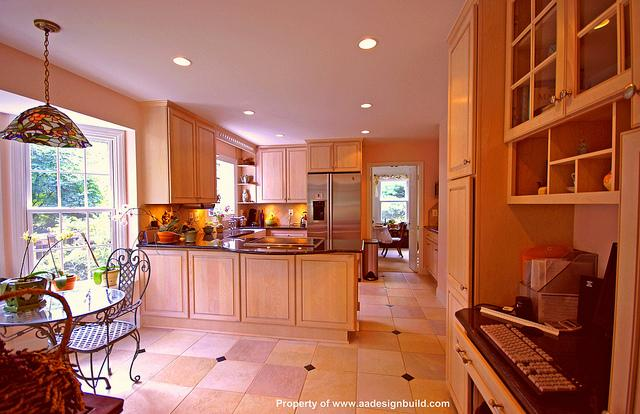What style of lamp is the one above the table? tiffany 